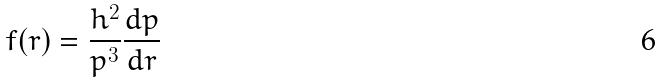<formula> <loc_0><loc_0><loc_500><loc_500>f ( r ) = \frac { h ^ { 2 } } { p ^ { 3 } } \frac { d p } { d r }</formula> 